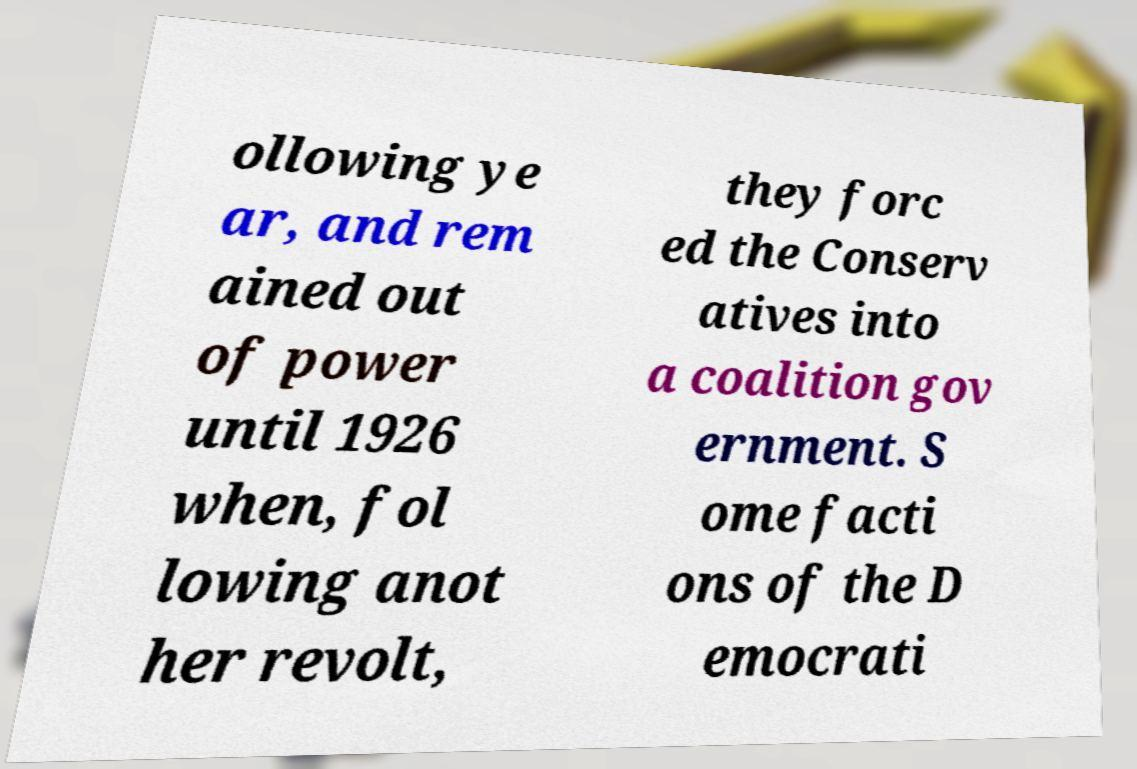Please read and relay the text visible in this image. What does it say? ollowing ye ar, and rem ained out of power until 1926 when, fol lowing anot her revolt, they forc ed the Conserv atives into a coalition gov ernment. S ome facti ons of the D emocrati 